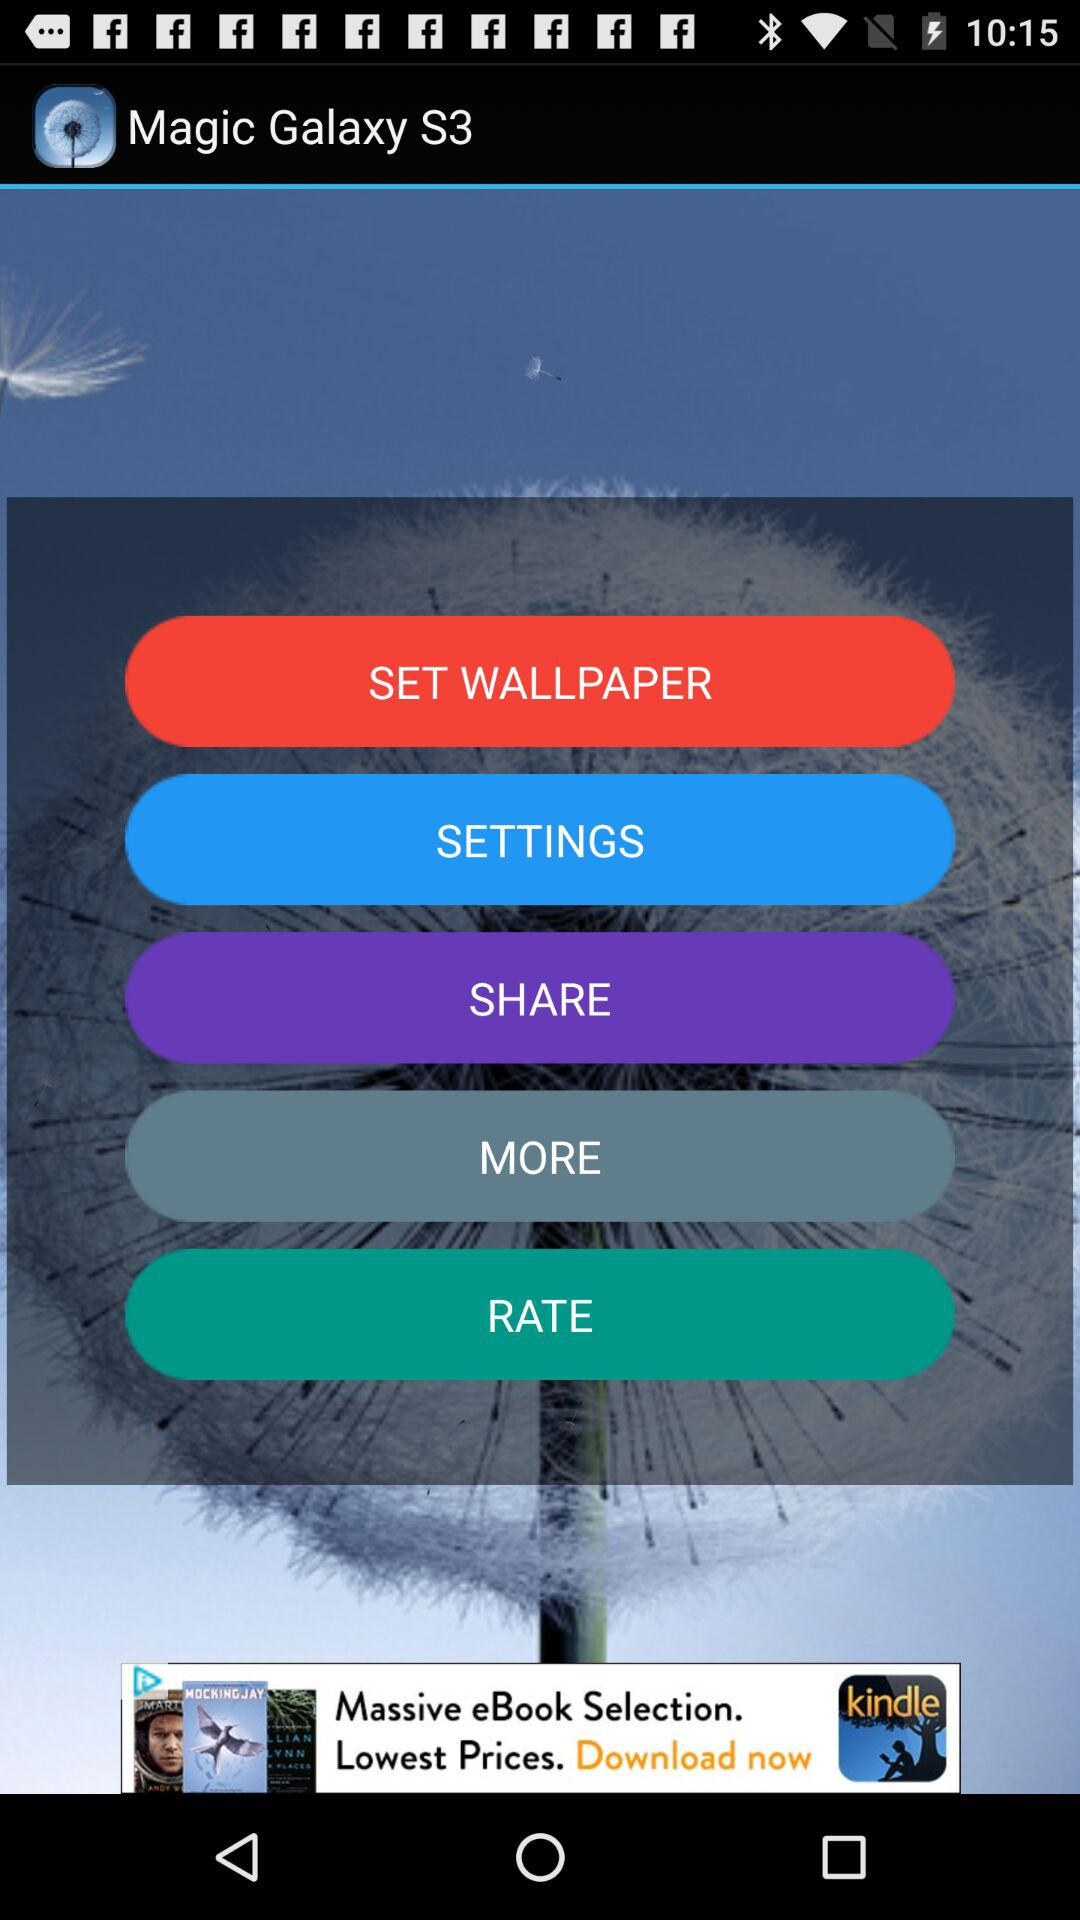What is the application name?
When the provided information is insufficient, respond with <no answer>. <no answer> 